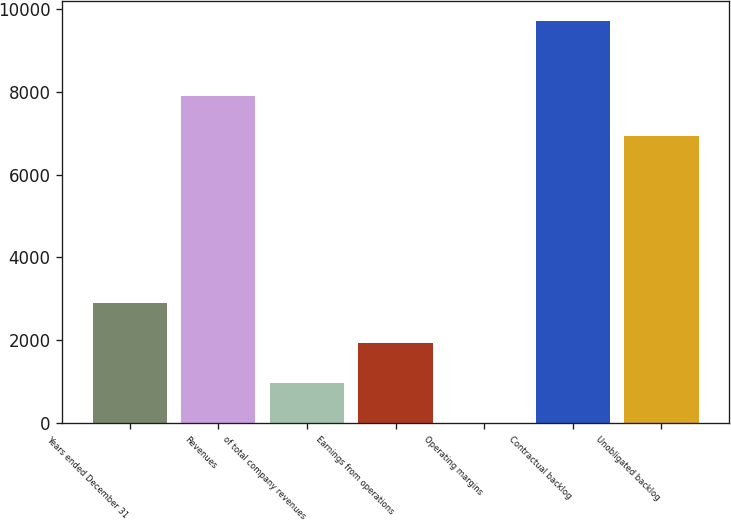Convert chart to OTSL. <chart><loc_0><loc_0><loc_500><loc_500><bar_chart><fcel>Years ended December 31<fcel>Revenues<fcel>of total company revenues<fcel>Earnings from operations<fcel>Operating margins<fcel>Contractual backlog<fcel>Unobligated backlog<nl><fcel>2912.01<fcel>7885.57<fcel>974.87<fcel>1943.44<fcel>6.3<fcel>9692<fcel>6917<nl></chart> 